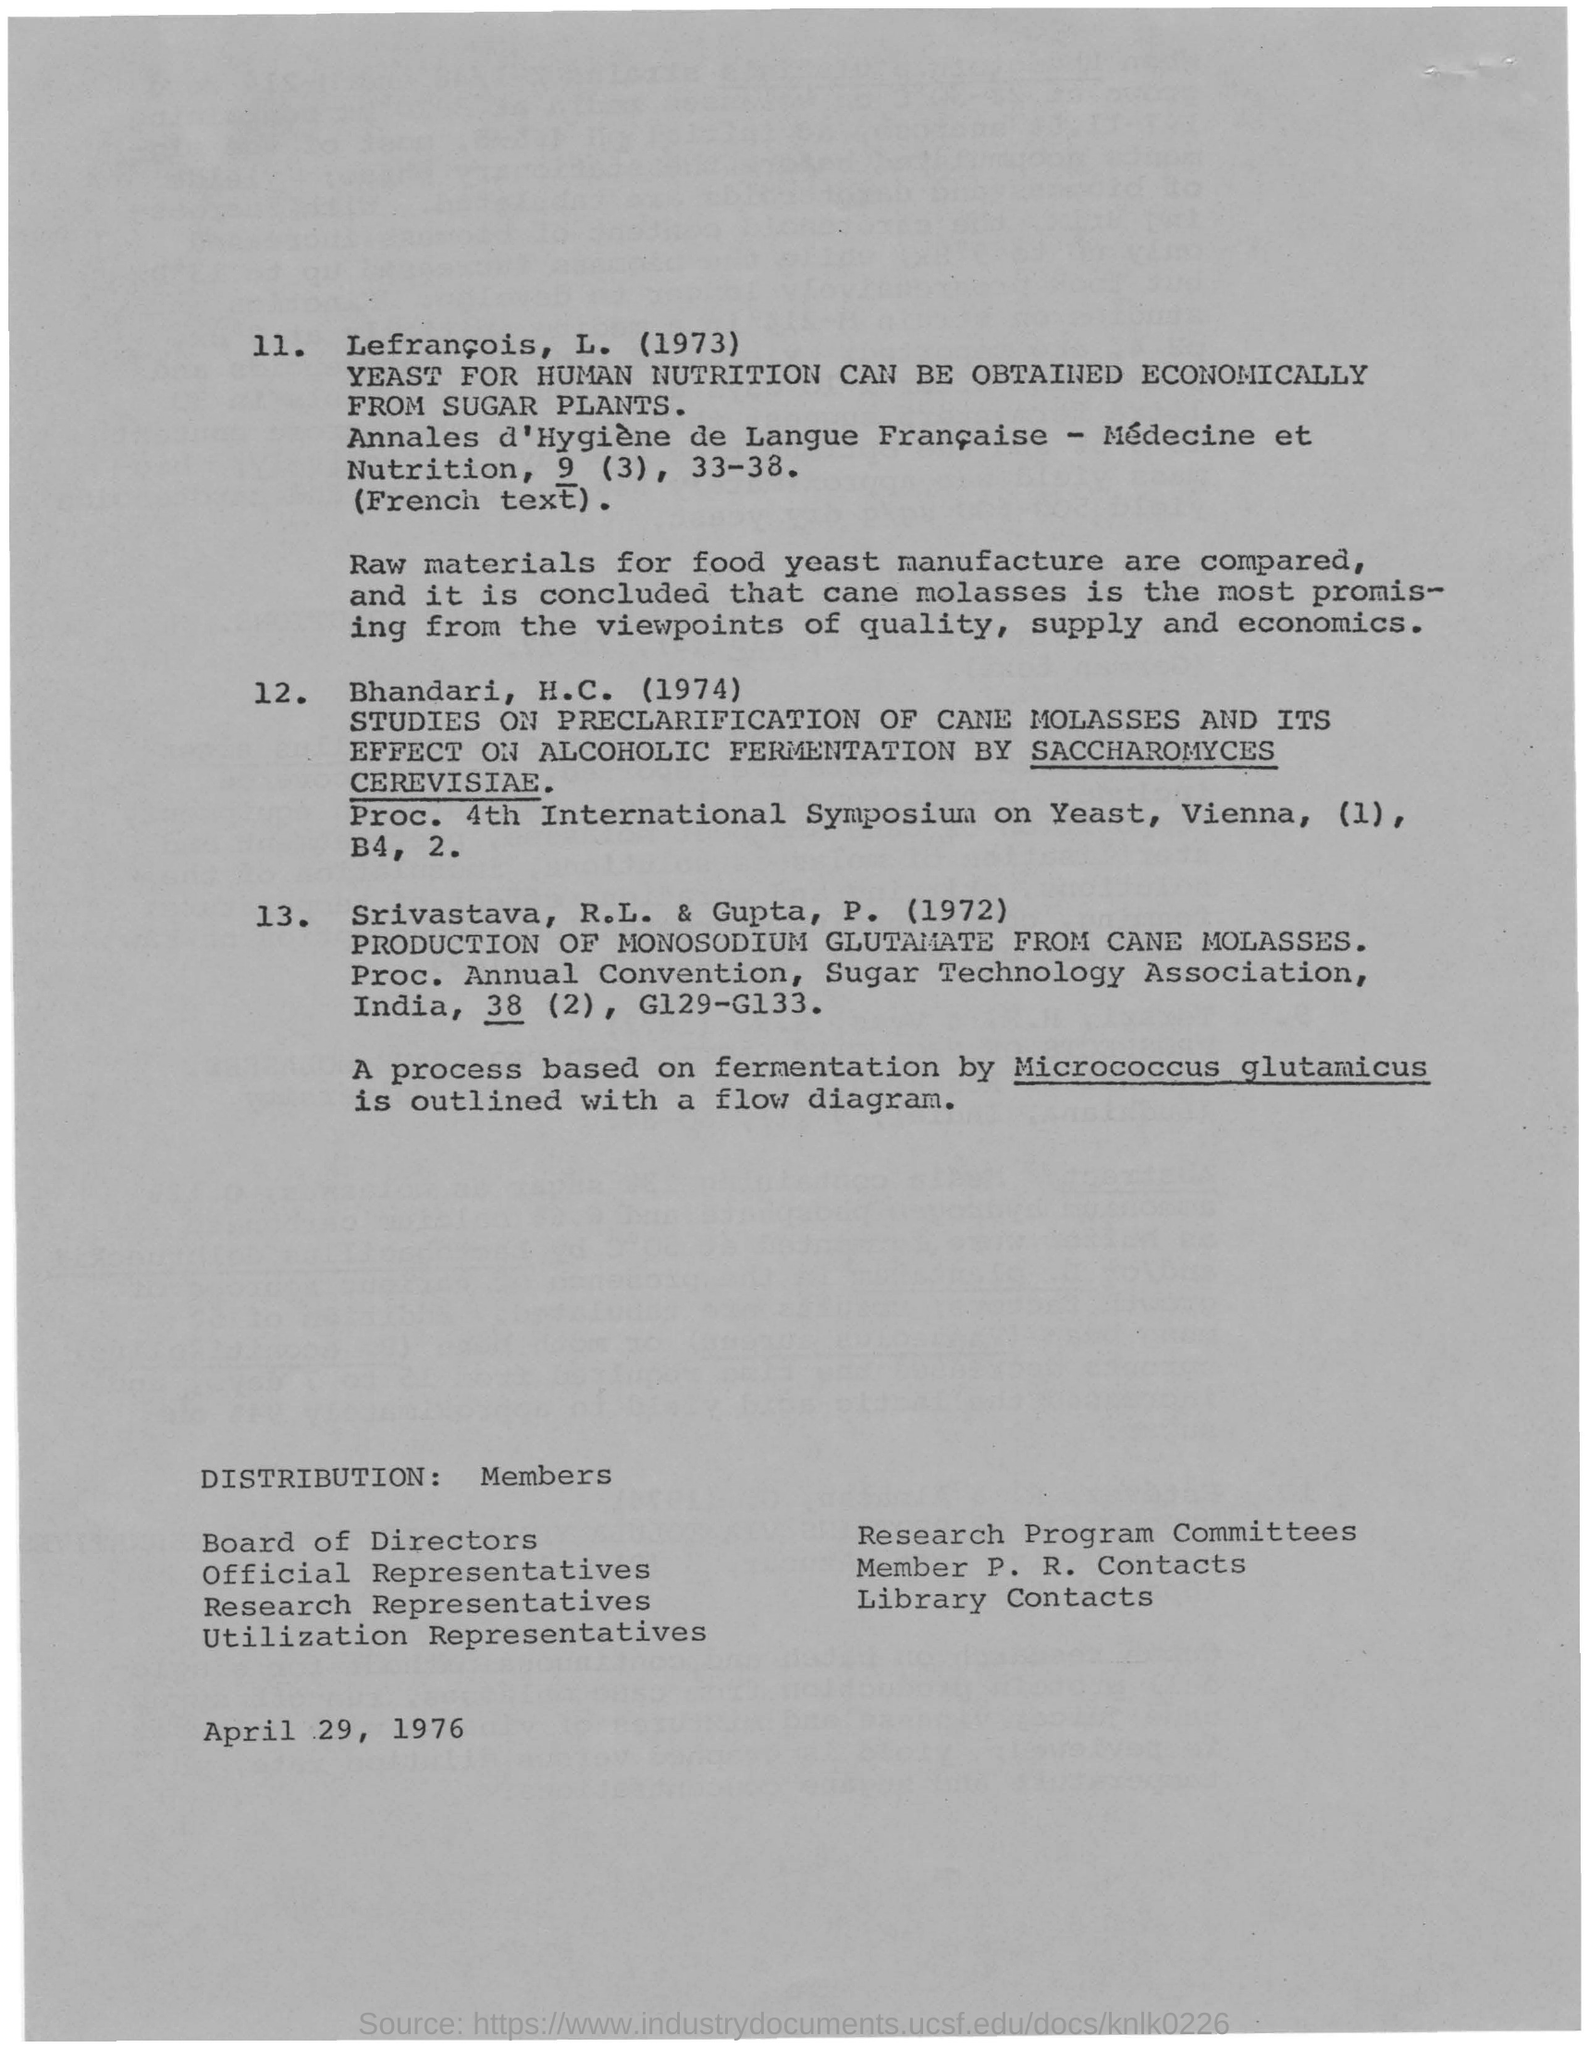Yeast for human nutrition can be obtained economically from which plants?
Make the answer very short. SUGAR PLANTS. Which raw material is the most promising from the viewpoints of quality, supply and economics?
Provide a succinct answer. Cane molasses. A process based on fermentation by what is outlined with a flow diagram?
Keep it short and to the point. Micrococcus glutamicus. 